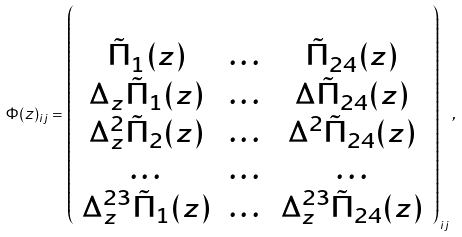<formula> <loc_0><loc_0><loc_500><loc_500>\Phi ( z ) _ { i j } = \left ( \begin{array} { c c c } \\ \tilde { \Pi } _ { 1 } ( z ) & \dots & \tilde { \Pi } _ { 2 4 } ( z ) \\ \Delta _ { z } \tilde { \Pi } _ { 1 } ( z ) & \dots & \Delta \tilde { \Pi } _ { 2 4 } ( z ) \\ \Delta _ { z } ^ { 2 } \tilde { \Pi } _ { 2 } ( z ) & \dots & \Delta ^ { 2 } \tilde { \Pi } _ { 2 4 } ( z ) \\ \dots & \dots & \dots \\ \Delta _ { z } ^ { 2 3 } \tilde { \Pi } _ { 1 } ( z ) & \dots & \Delta _ { z } ^ { 2 3 } \tilde { \Pi } _ { 2 4 } ( z ) \\ \end{array} \right ) _ { i j } ,</formula> 